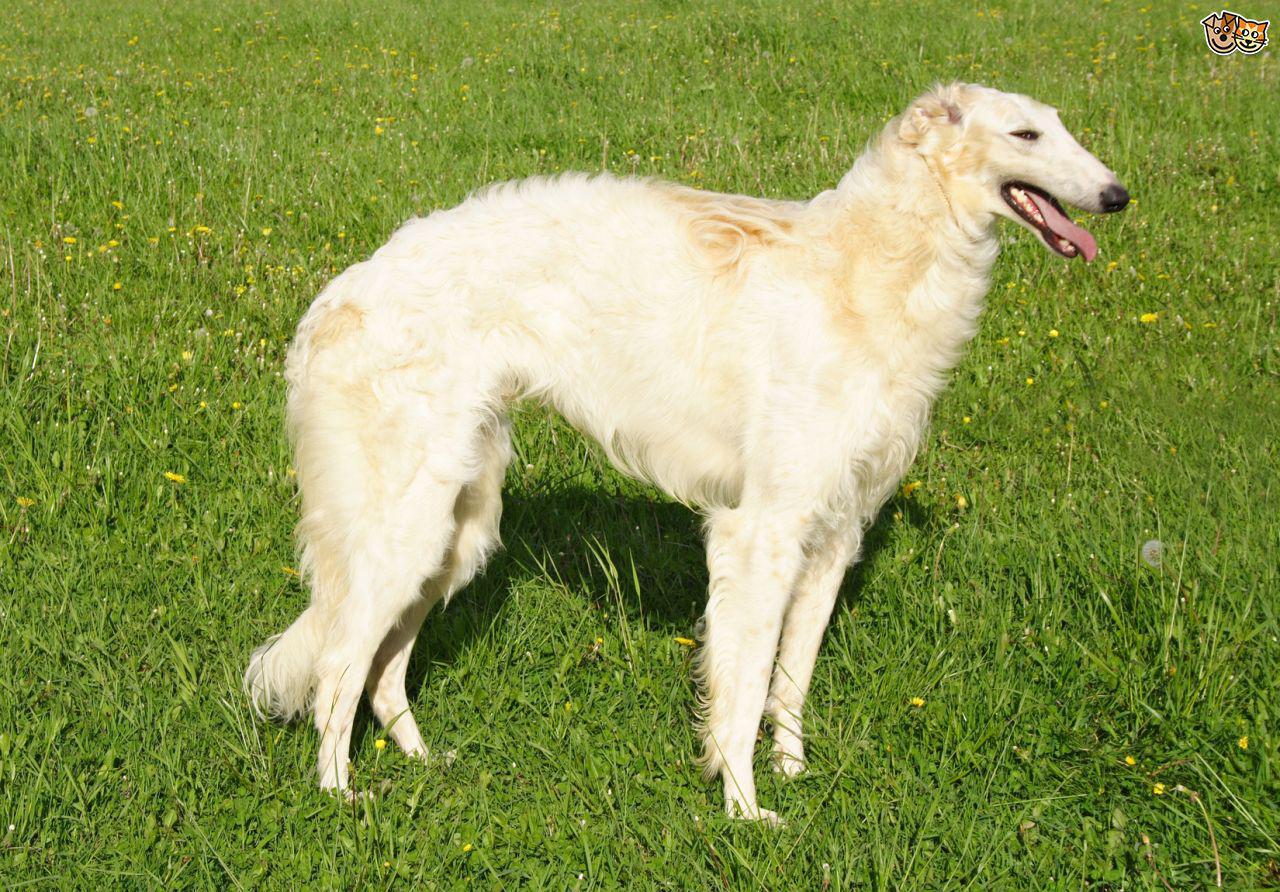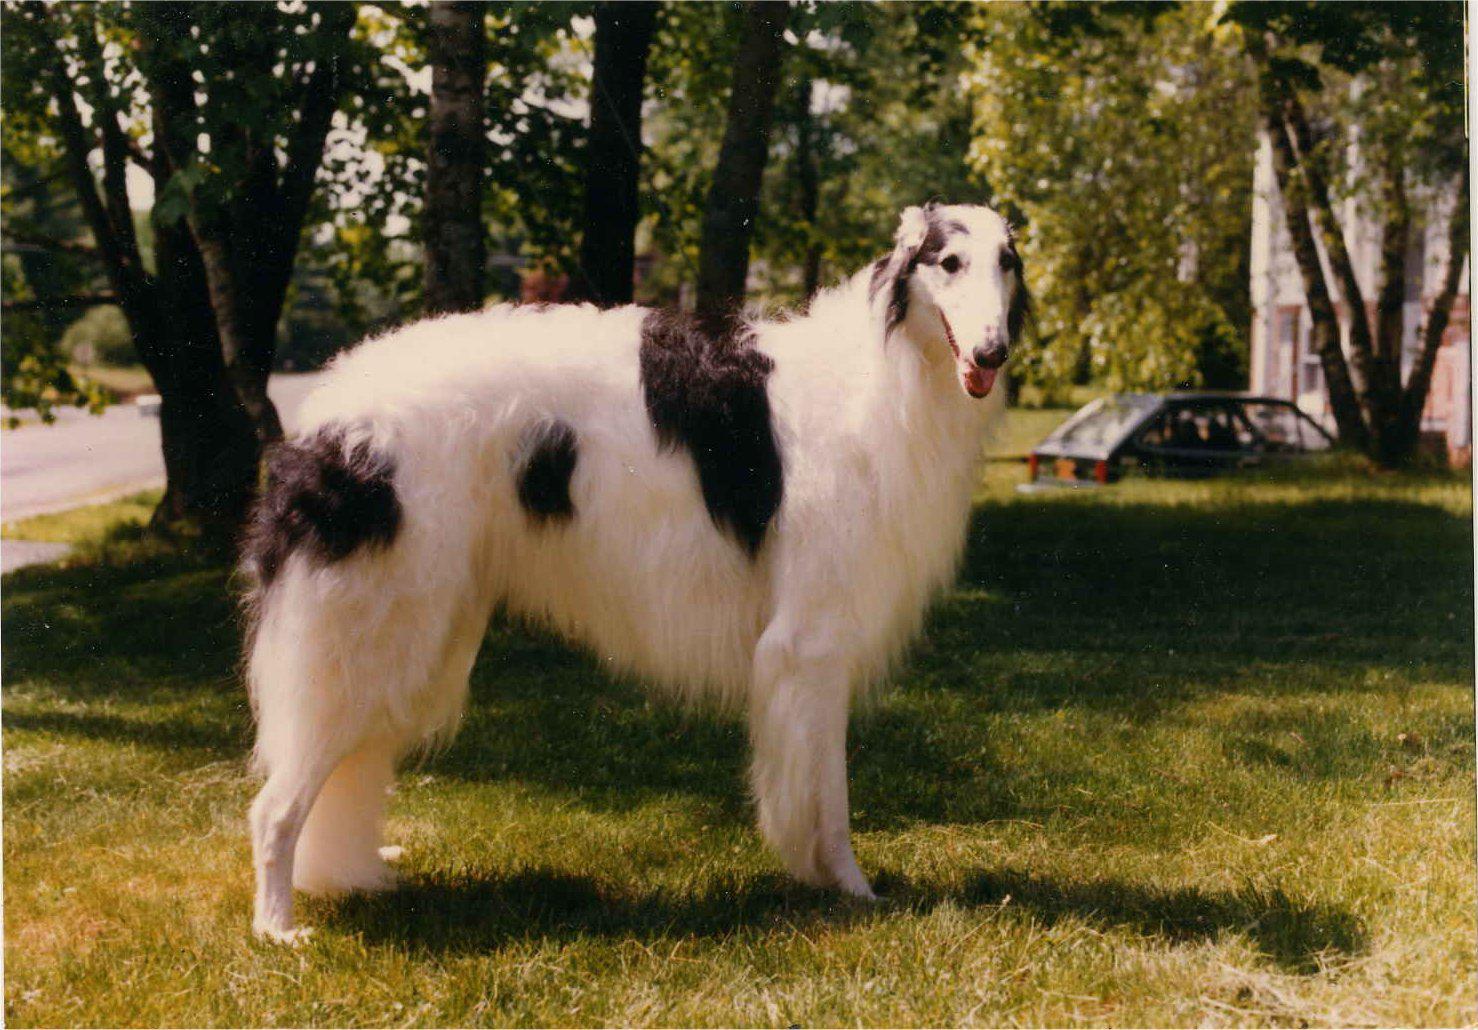The first image is the image on the left, the second image is the image on the right. For the images displayed, is the sentence "The dog in the image on the left is facing left and the dog in the image on the right is facing right." factually correct? Answer yes or no. No. 